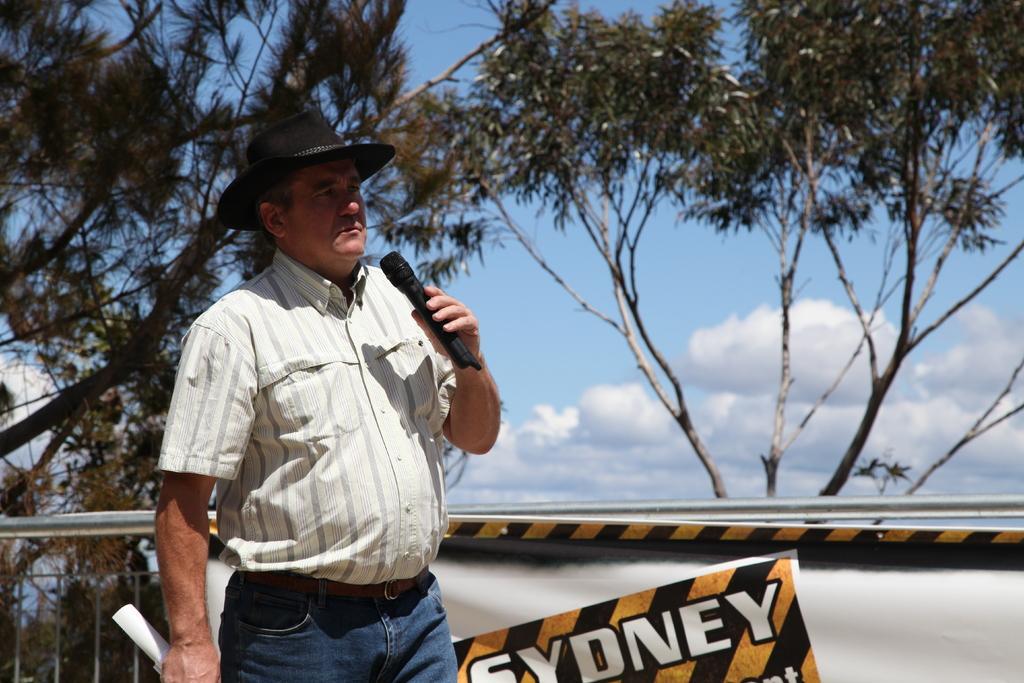Describe this image in one or two sentences. In the picture we can see a man standing and holding a microphone and talking in it and he is in shirt and wearing a black color hat and behind him we can see a railing with a poster on it, we can see a name Sydney and behind the railing we can see some trees and a sky with clouds. 